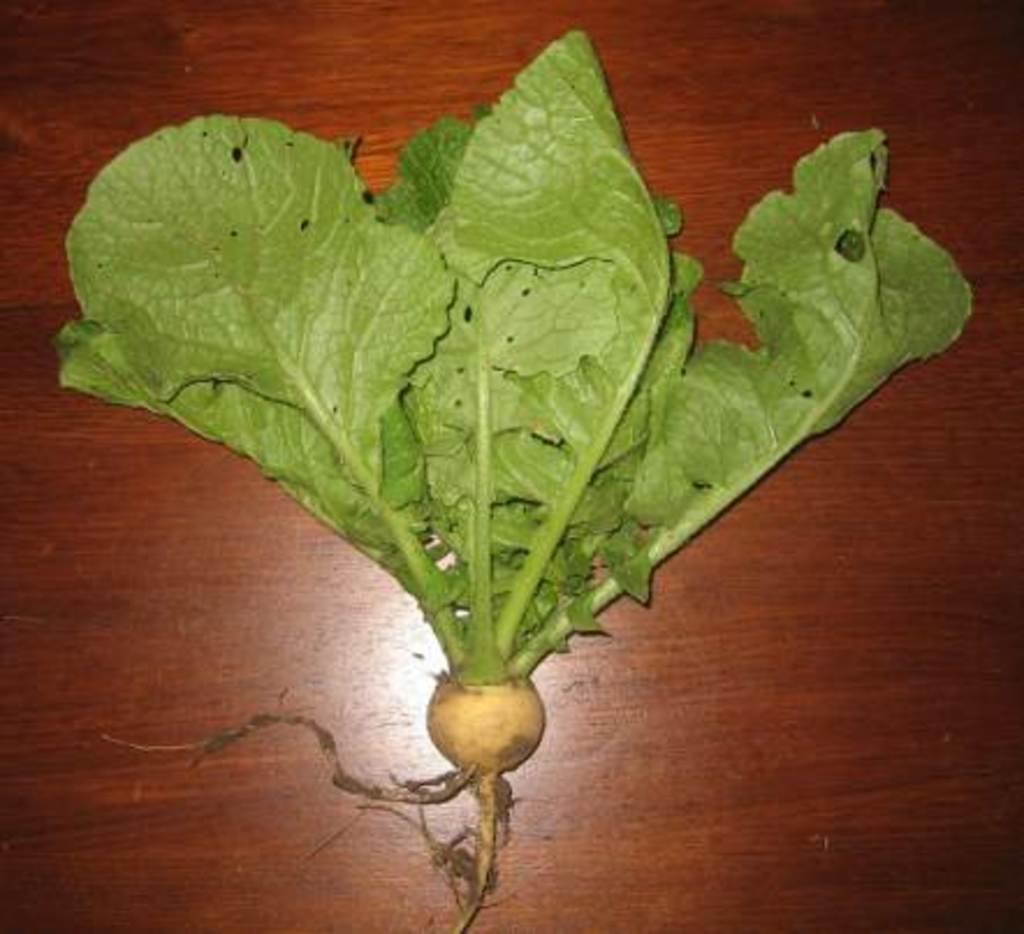How would you summarize this image in a sentence or two? This is the picture of a table on which there is a radish. 